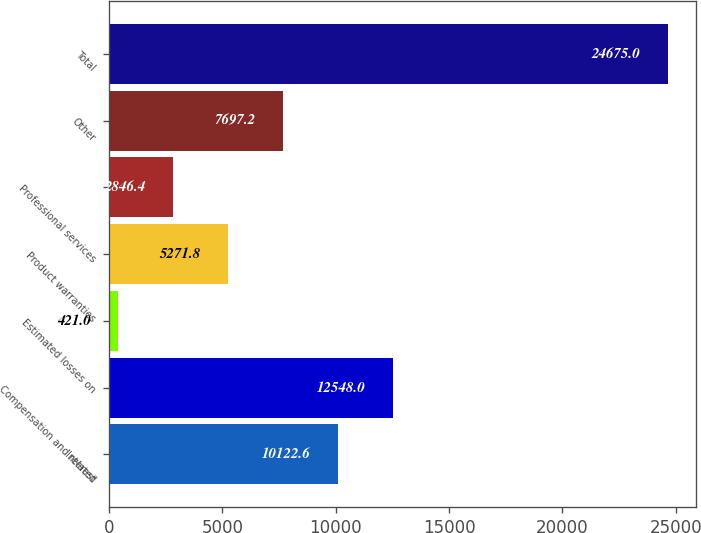Convert chart to OTSL. <chart><loc_0><loc_0><loc_500><loc_500><bar_chart><fcel>Interest<fcel>Compensation and related<fcel>Estimated losses on<fcel>Product warranties<fcel>Professional services<fcel>Other<fcel>Total<nl><fcel>10122.6<fcel>12548<fcel>421<fcel>5271.8<fcel>2846.4<fcel>7697.2<fcel>24675<nl></chart> 